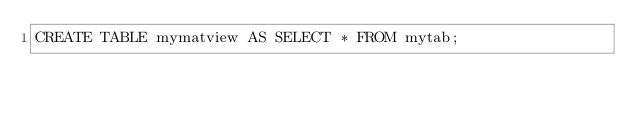<code> <loc_0><loc_0><loc_500><loc_500><_SQL_>CREATE TABLE mymatview AS SELECT * FROM mytab;
</code> 